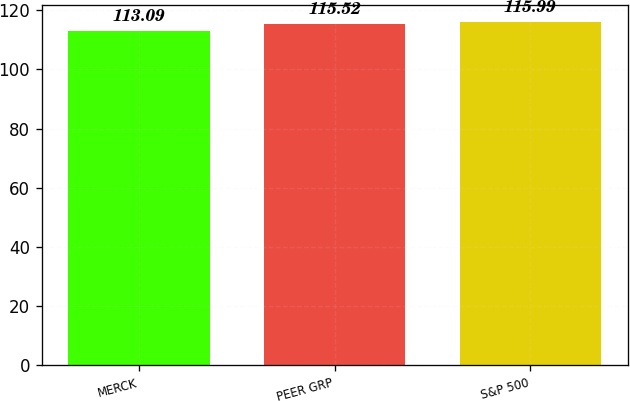Convert chart to OTSL. <chart><loc_0><loc_0><loc_500><loc_500><bar_chart><fcel>MERCK<fcel>PEER GRP<fcel>S&P 500<nl><fcel>113.09<fcel>115.52<fcel>115.99<nl></chart> 